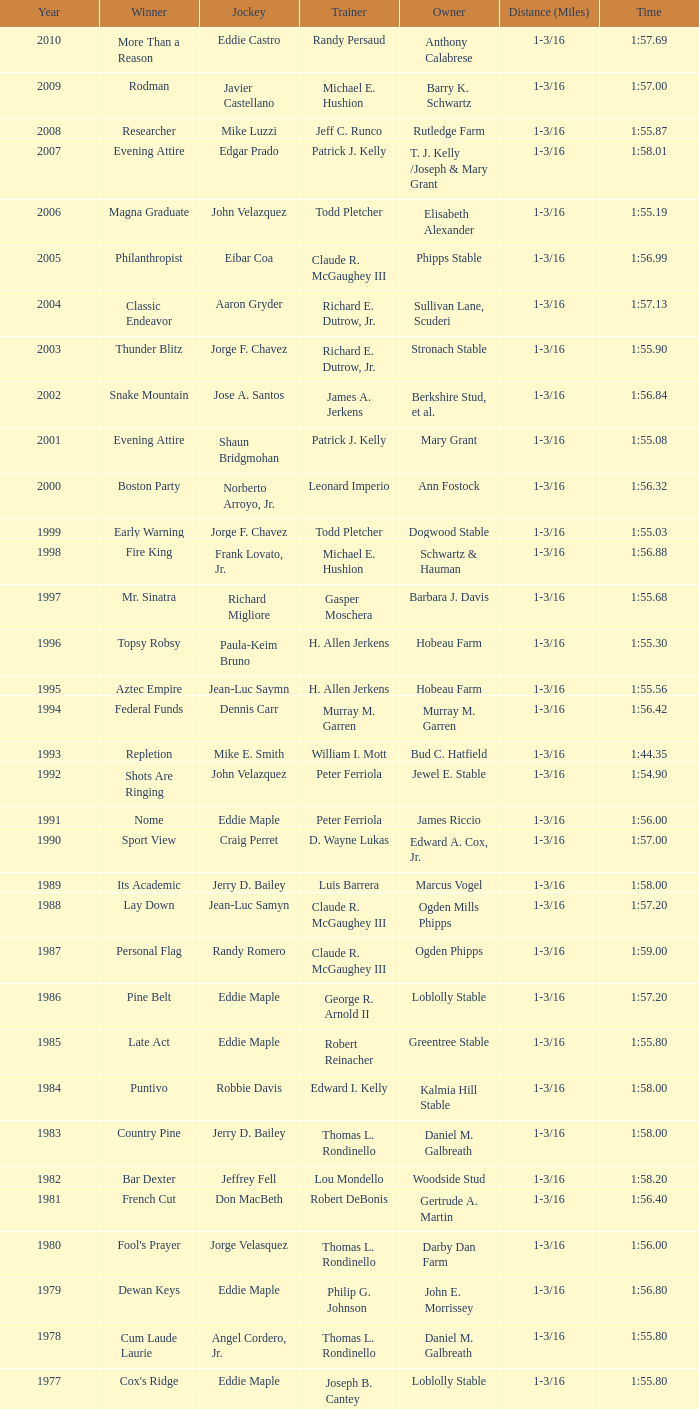What time did the victorious horse salford ii achieve? 1:44.20. 